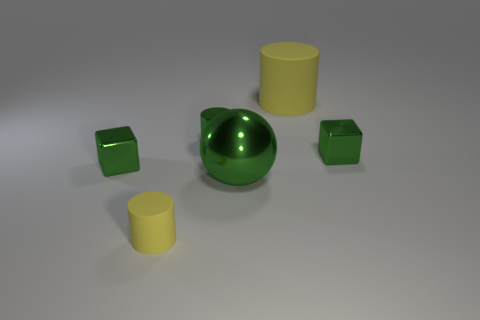What is the color of the cylinder behind the tiny green metal thing behind the tiny metallic cube right of the big green shiny sphere?
Your answer should be very brief. Yellow. Are there any small gray things of the same shape as the small yellow thing?
Your answer should be compact. No. Is the number of big green things in front of the green ball the same as the number of cylinders in front of the big matte cylinder?
Offer a terse response. No. Do the rubber thing that is left of the big rubber object and the big green metallic thing have the same shape?
Provide a succinct answer. No. Is the tiny yellow thing the same shape as the big yellow matte object?
Offer a very short reply. Yes. What number of shiny things are either large purple cylinders or big yellow objects?
Give a very brief answer. 0. What is the material of the other cylinder that is the same color as the big rubber cylinder?
Offer a very short reply. Rubber. Do the green cylinder and the green metallic sphere have the same size?
Offer a very short reply. No. What number of objects are either matte things or yellow cylinders that are left of the large green sphere?
Your answer should be very brief. 2. There is a cylinder that is the same size as the sphere; what is its material?
Your response must be concise. Rubber. 